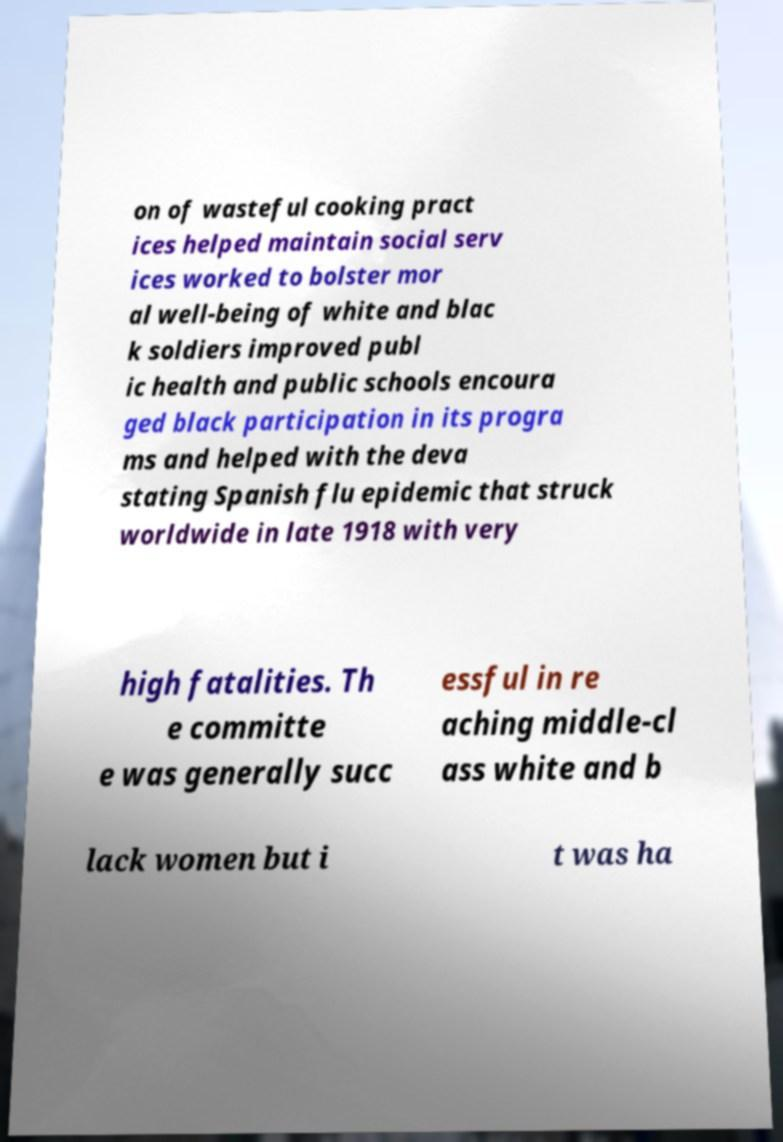Could you extract and type out the text from this image? on of wasteful cooking pract ices helped maintain social serv ices worked to bolster mor al well-being of white and blac k soldiers improved publ ic health and public schools encoura ged black participation in its progra ms and helped with the deva stating Spanish flu epidemic that struck worldwide in late 1918 with very high fatalities. Th e committe e was generally succ essful in re aching middle-cl ass white and b lack women but i t was ha 